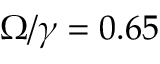<formula> <loc_0><loc_0><loc_500><loc_500>\Omega / \gamma = 0 . 6 5</formula> 